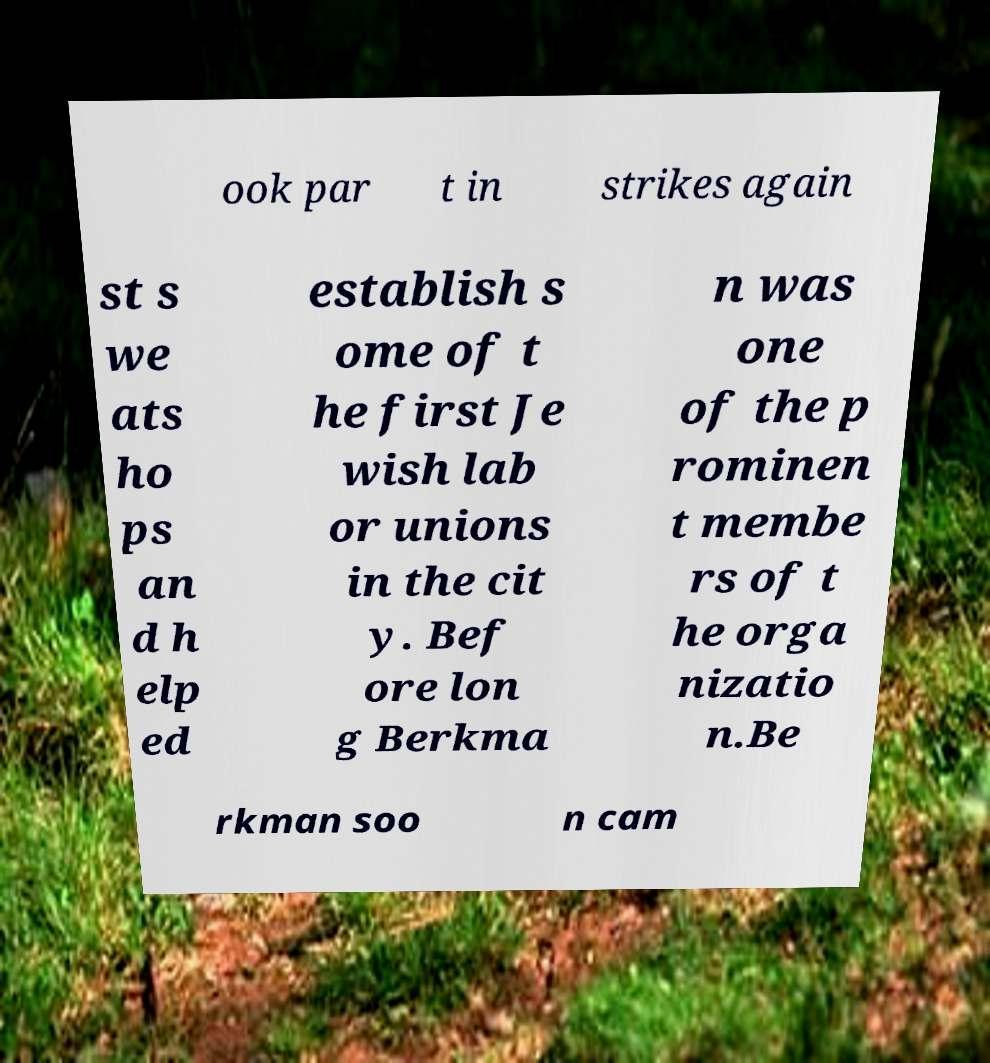Please read and relay the text visible in this image. What does it say? ook par t in strikes again st s we ats ho ps an d h elp ed establish s ome of t he first Je wish lab or unions in the cit y. Bef ore lon g Berkma n was one of the p rominen t membe rs of t he orga nizatio n.Be rkman soo n cam 